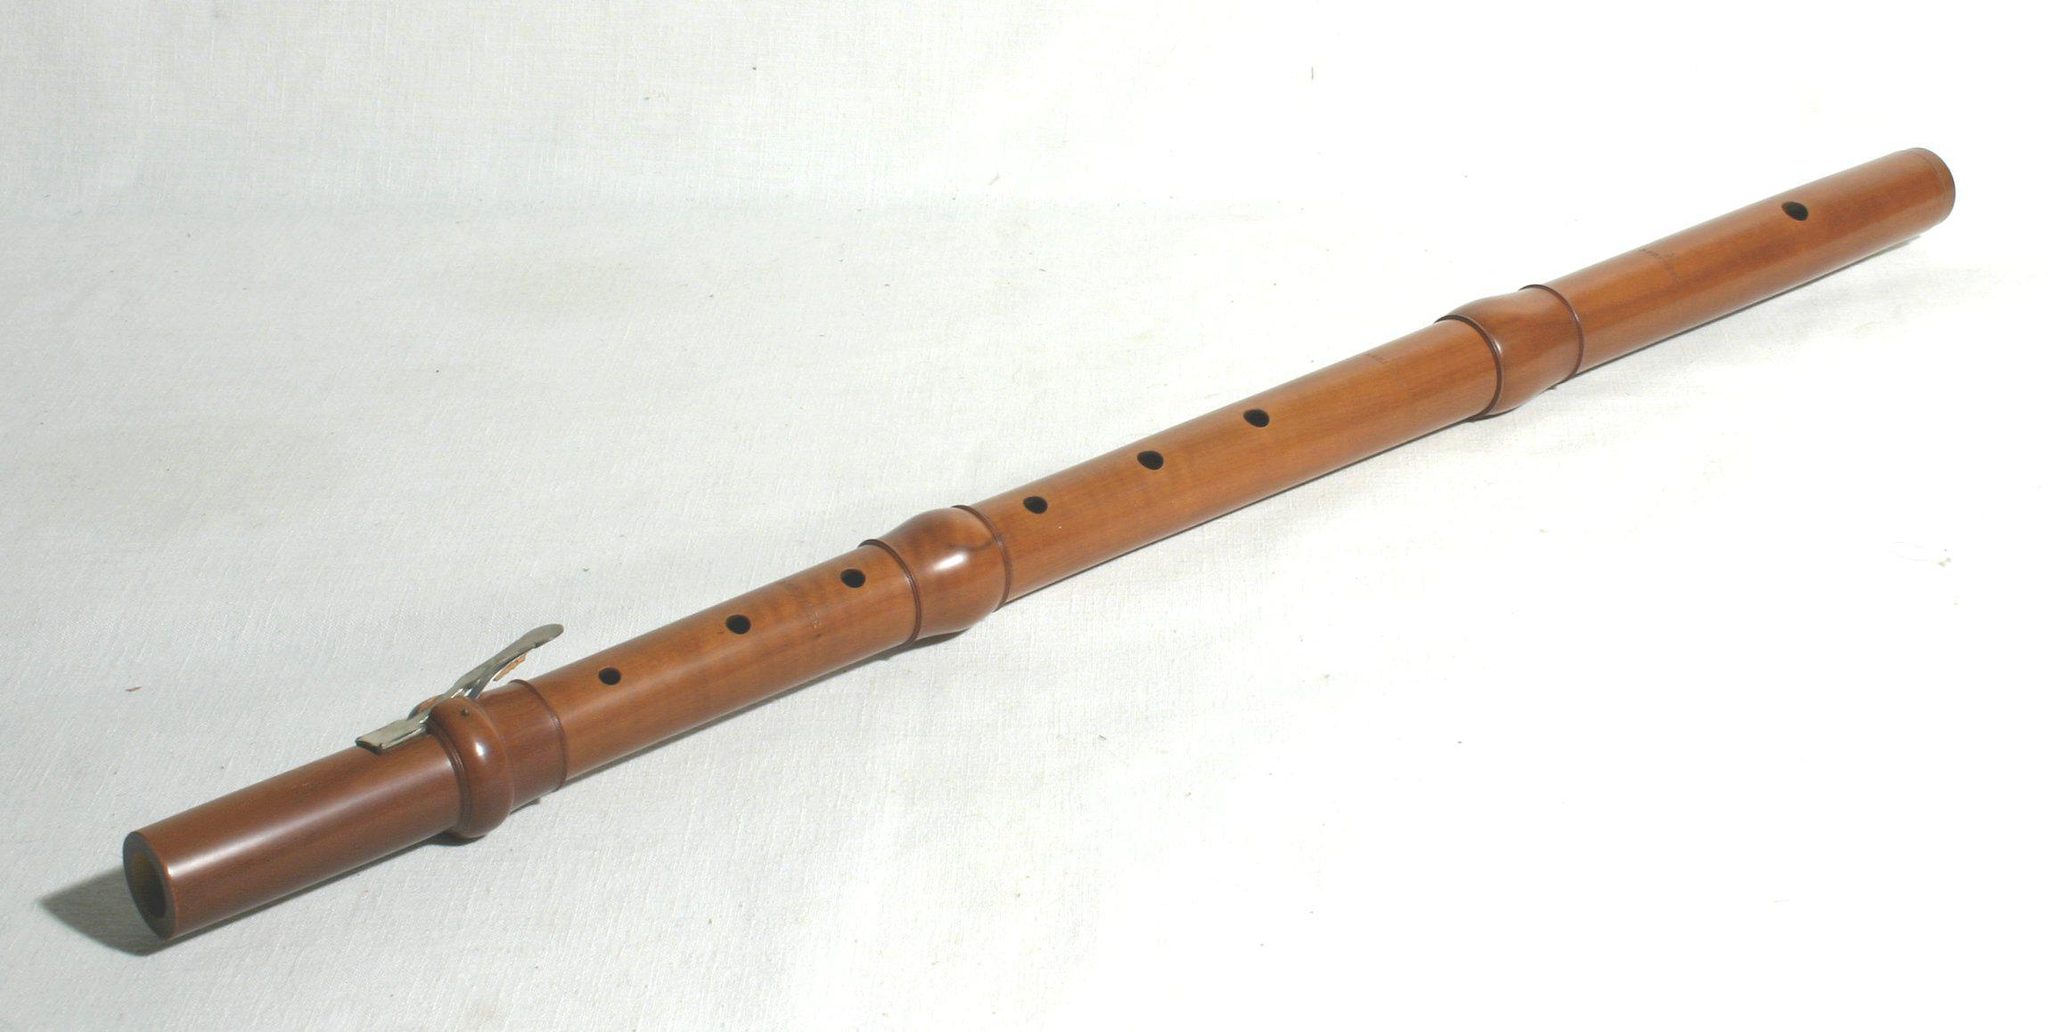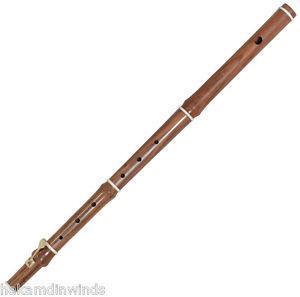The first image is the image on the left, the second image is the image on the right. Evaluate the accuracy of this statement regarding the images: "The left and right images do not contain the same number of items, but the combined images include at least four items of the same color.". Is it true? Answer yes or no. No. The first image is the image on the left, the second image is the image on the right. Evaluate the accuracy of this statement regarding the images: "There are two musical instruments.". Is it true? Answer yes or no. Yes. 